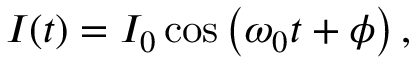<formula> <loc_0><loc_0><loc_500><loc_500>I ( t ) = I _ { 0 } \cos \left ( \omega _ { 0 } t + \phi \right ) ,</formula> 